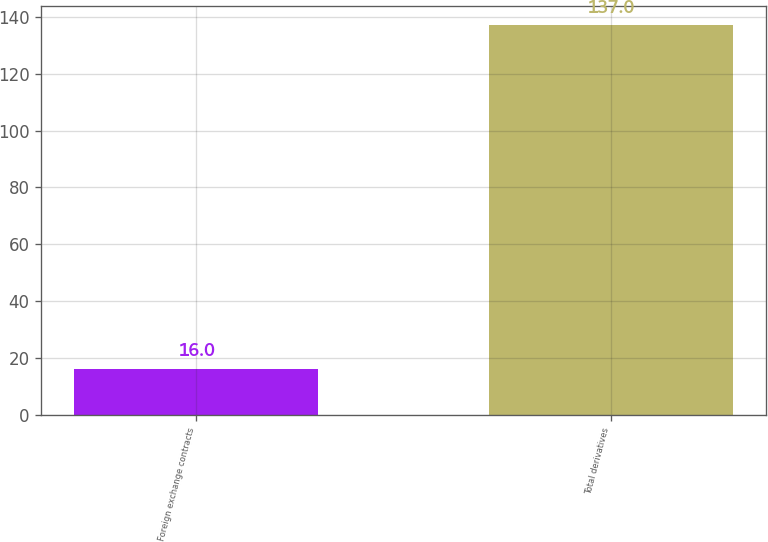Convert chart. <chart><loc_0><loc_0><loc_500><loc_500><bar_chart><fcel>Foreign exchange contracts<fcel>Total derivatives<nl><fcel>16<fcel>137<nl></chart> 